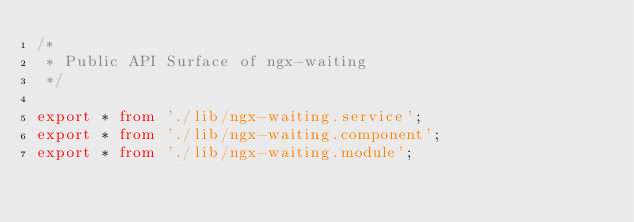Convert code to text. <code><loc_0><loc_0><loc_500><loc_500><_TypeScript_>/*
 * Public API Surface of ngx-waiting
 */

export * from './lib/ngx-waiting.service';
export * from './lib/ngx-waiting.component';
export * from './lib/ngx-waiting.module';
</code> 